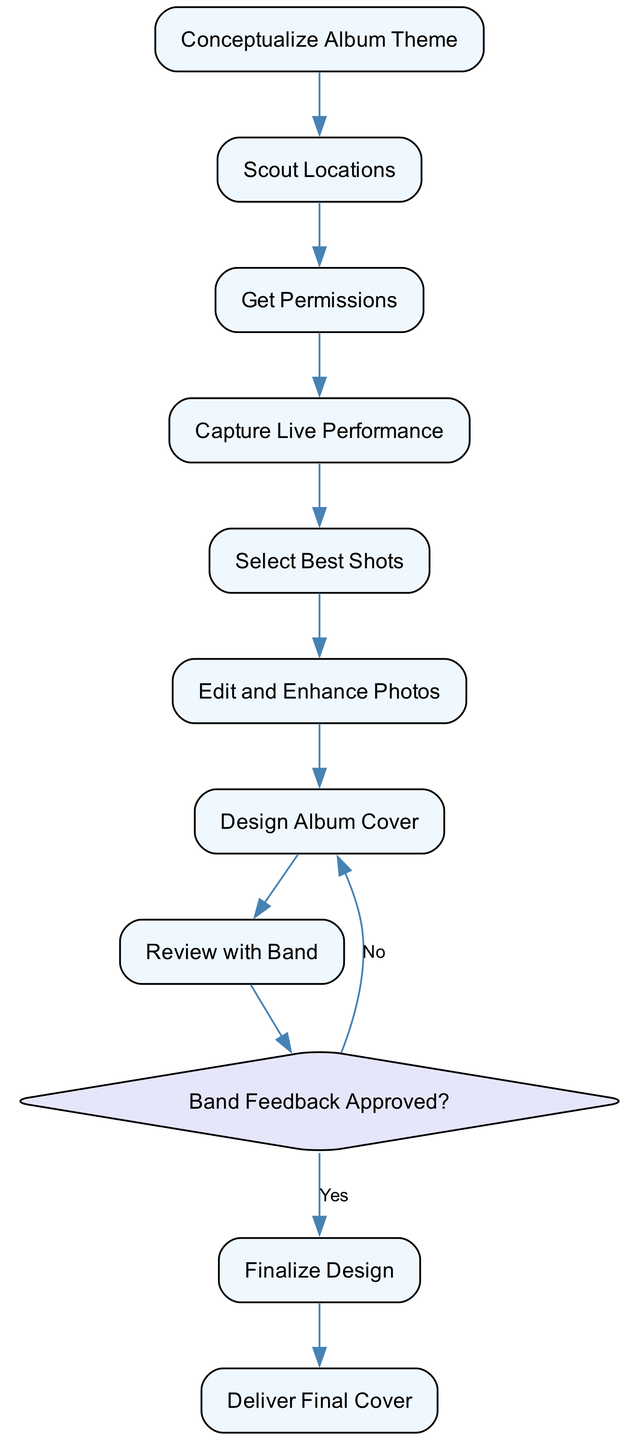What is the first activity in the workflow? The first activity is "Conceptualize Album Theme," which is where the process begins by brainstorming ideas with the band.
Answer: Conceptualize Album Theme How many decision points are present in the diagram? There is one decision point, which checks if the band has approved the album cover design.
Answer: 1 What activity follows "Select Best Shots"? "Edit and Enhance Photos" follows "Select Best Shots" as the next step in the workflow.
Answer: Edit and Enhance Photos Which activity comes before "Deliver Final Cover"? "Finalize Design" comes before "Deliver Final Cover," as it involves making final adjustments to the album cover.
Answer: Finalize Design What is the condition for going back to "Design Album Cover"? The condition is "No," meaning if the band does not approve the feedback, the process returns to redesign the cover.
Answer: No How many activities are involved in the diagram? There are ten activities that illustrate the steps involved in creating a rock album cover.
Answer: 10 What do you do after capturing the live performance? After capturing the live performance, the next step is to "Select Best Shots," where the best photographs are chosen for editing.
Answer: Select Best Shots What is the final outcome or deliverable of the workflow? The final outcome is the "Deliver Final Cover," which is the high-resolution file provided to the band's label or distribution team.
Answer: Deliver Final Cover 